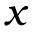Convert formula to latex. <formula><loc_0><loc_0><loc_500><loc_500>x</formula> 